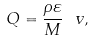Convert formula to latex. <formula><loc_0><loc_0><loc_500><loc_500>Q = \frac { \rho \varepsilon } { M } \ v ,</formula> 